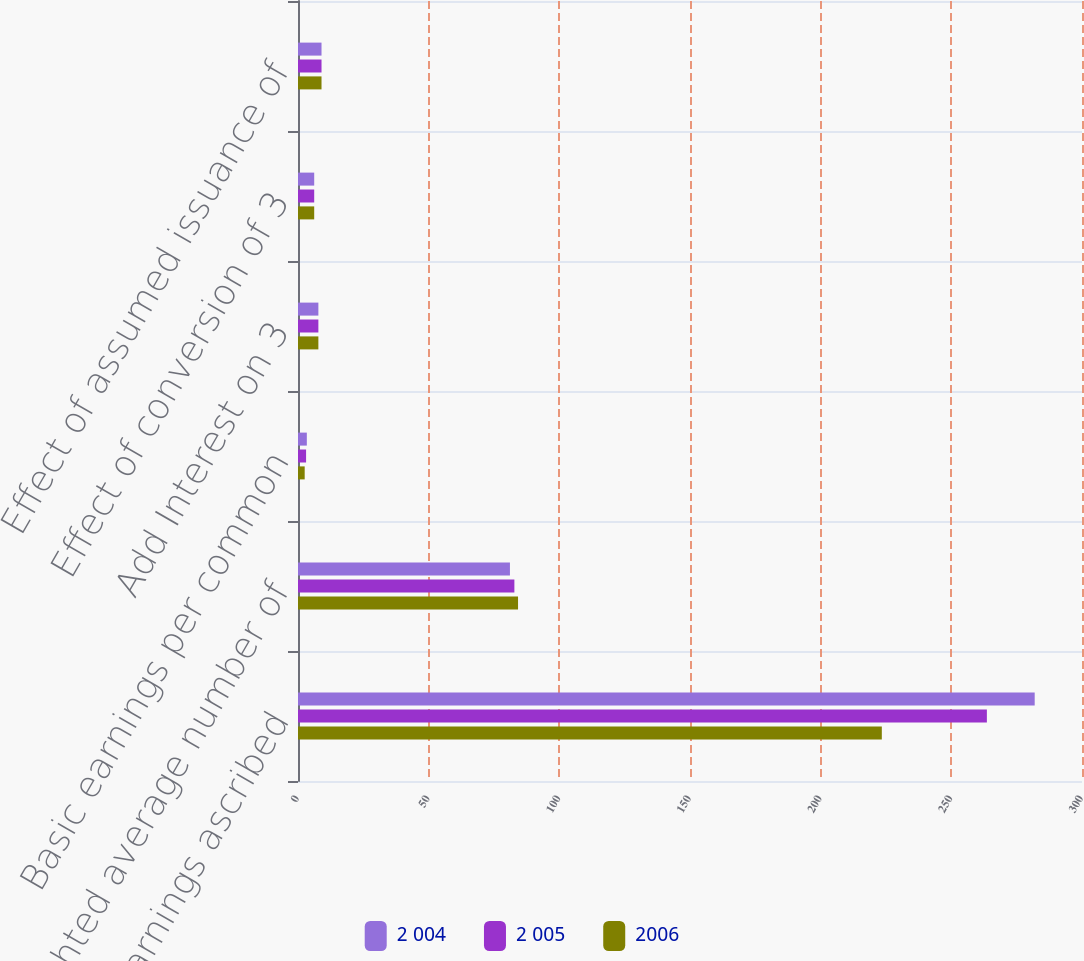Convert chart to OTSL. <chart><loc_0><loc_0><loc_500><loc_500><stacked_bar_chart><ecel><fcel>Net earnings ascribed<fcel>Weighted average number of<fcel>Basic earnings per common<fcel>Add Interest on 3<fcel>Effect of conversion of 3<fcel>Effect of assumed issuance of<nl><fcel>2 004<fcel>281.9<fcel>81.1<fcel>3.38<fcel>7.8<fcel>6.2<fcel>9<nl><fcel>2 005<fcel>263.6<fcel>82.8<fcel>3.09<fcel>7.8<fcel>6.2<fcel>9<nl><fcel>2006<fcel>223.4<fcel>84.2<fcel>2.56<fcel>7.8<fcel>6.2<fcel>9<nl></chart> 